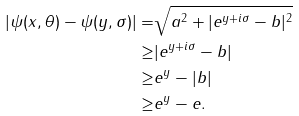Convert formula to latex. <formula><loc_0><loc_0><loc_500><loc_500>| \psi ( x , \theta ) - \psi ( y , \sigma ) | = & \sqrt { a ^ { 2 } + | e ^ { y + i \sigma } - b | ^ { 2 } } \\ \geq & | e ^ { y + i \sigma } - b | \\ \geq & e ^ { y } - | b | \\ \geq & e ^ { y } - e .</formula> 